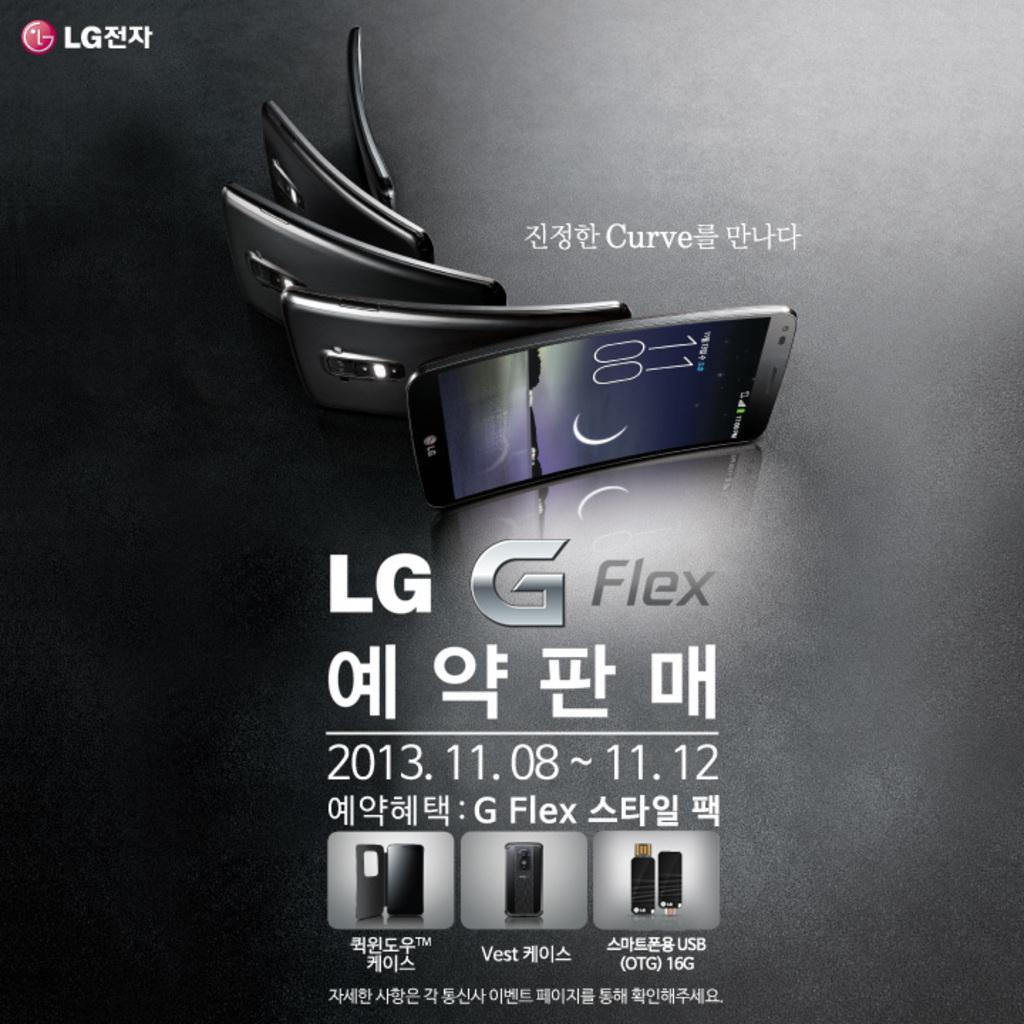<image>
Share a concise interpretation of the image provided. Poster for a phone which says LG on the bottom. 